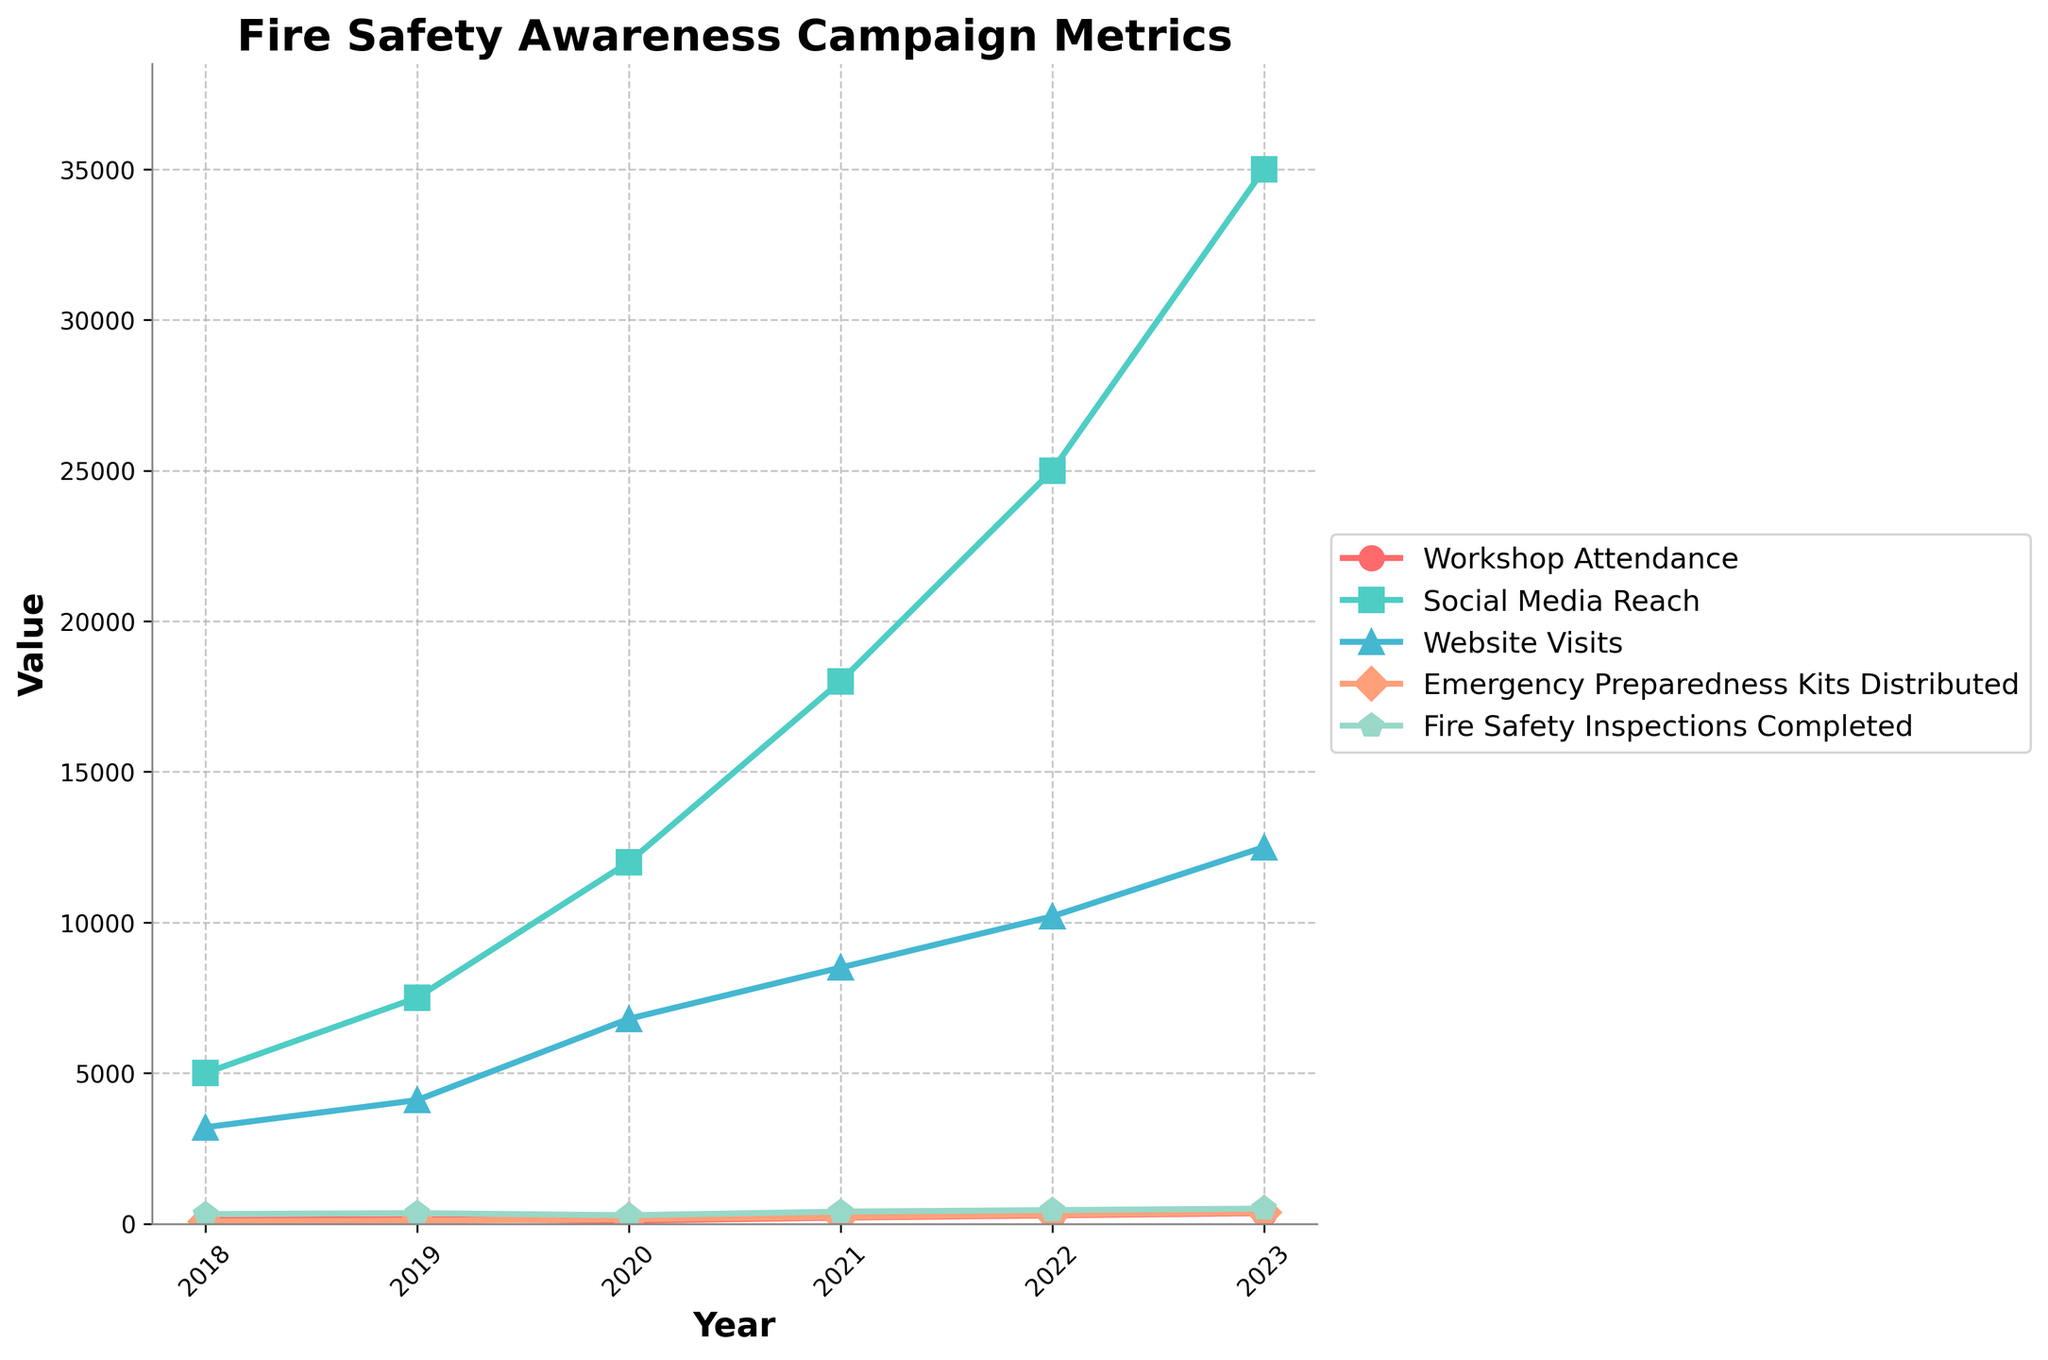What was the total social media reach over the 6 years? To find the total social media reach over the 6 years, add the yearly social media reach values: \(5000 + 7500 + 12000 + 18000 + 25000 + 35000 = 105500\)
Answer: 105500 What year had the highest workshop attendance? Look at the plot for the peak point in the "Workshop Attendance" line and note the corresponding year on the x-axis. The highest attendance is 350 in the year 2023.
Answer: 2023 How did website visits change from 2020 to 2023? Check the values for "Website Visits" in 2020 and 2023 and calculate the difference: \(12500 - 6800 = 5700\). This represents an increase of 5700 visits from 2020 to 2023.
Answer: Increased by 5700 Were there any years where all metrics increased compared to the previous year? Visually inspect the plotted lines and check if each metric's value in successive years is higher than the previous one. In 2019, 2021, 2022, and 2023, all metrics show an increase compared to the previous year.
Answer: 2019, 2021, 2022, 2023 How does the trend of Fire Safety Inspections Completed compare to Workshop Attendance over the years? Examine the two plotted lines and observe their general directions over time. Both metrics show an increasing trend; however, "Fire Safety Inspections Completed" shows a more stable and less steep increase compared to the sharp rise in "Workshop Attendance."
Answer: Both increasing, but Workshop Attendance increased more steeply What is the average number of Website Visits from 2018 to 2023? To calculate the average, first sum the yearly Website Visits and then divide by the number of years: \((3200 + 4100 + 6800 + 8500 + 10200 + 12500) / 6 \approx 7383\)
Answer: 7383 